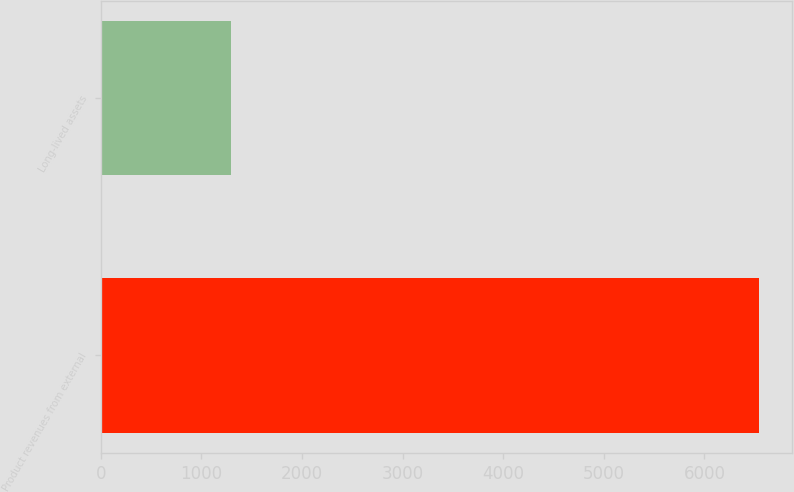Convert chart. <chart><loc_0><loc_0><loc_500><loc_500><bar_chart><fcel>Product revenues from external<fcel>Long-lived assets<nl><fcel>6545.8<fcel>1296.5<nl></chart> 